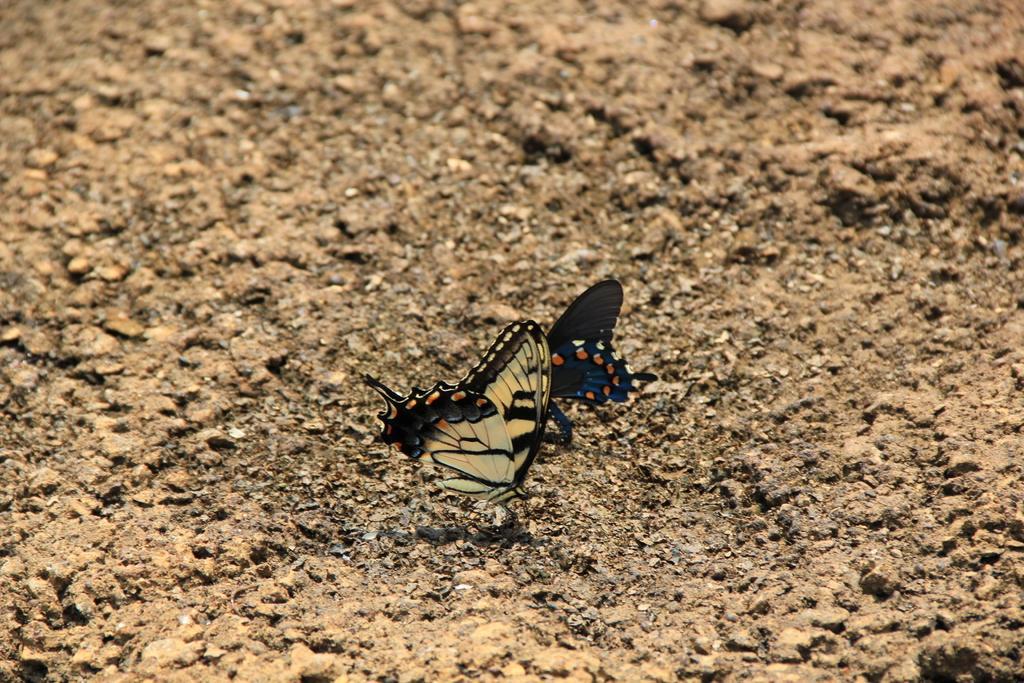Please provide a concise description of this image. In this image there are two butterflies on a land. 